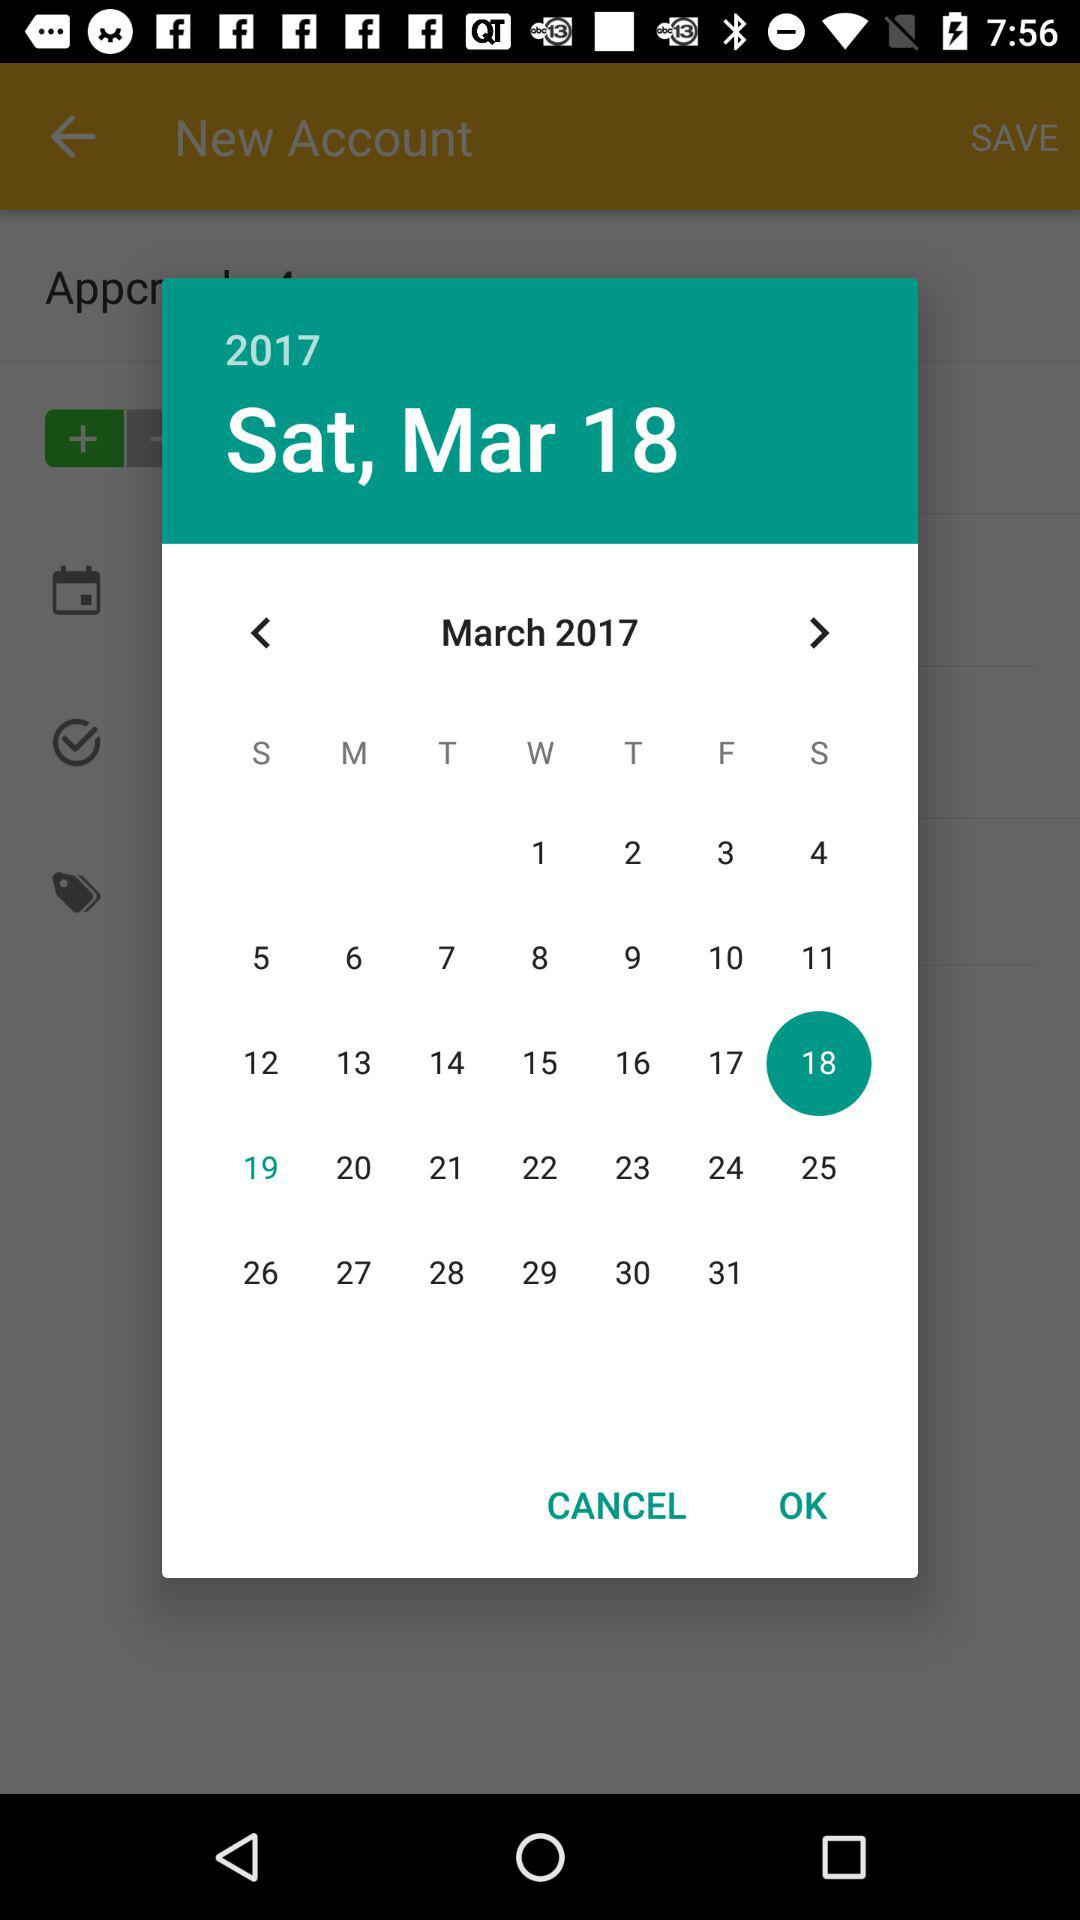What is the day on March 18, 2017? The day is Saturday. 